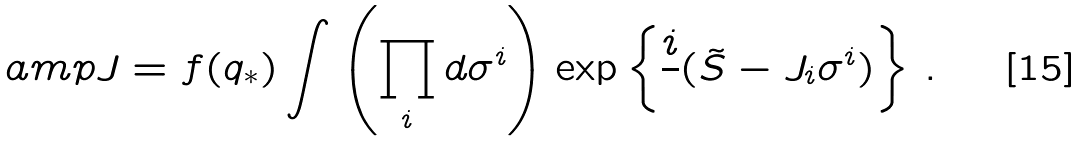<formula> <loc_0><loc_0><loc_500><loc_500>\ a m p J = f ( q _ { \ast } ) \int \left ( \prod _ { i } d \sigma ^ { i } \right ) \exp \left \{ \frac { i } { } ( \tilde { S } - J _ { i } \sigma ^ { i } ) \right \} \, .</formula> 